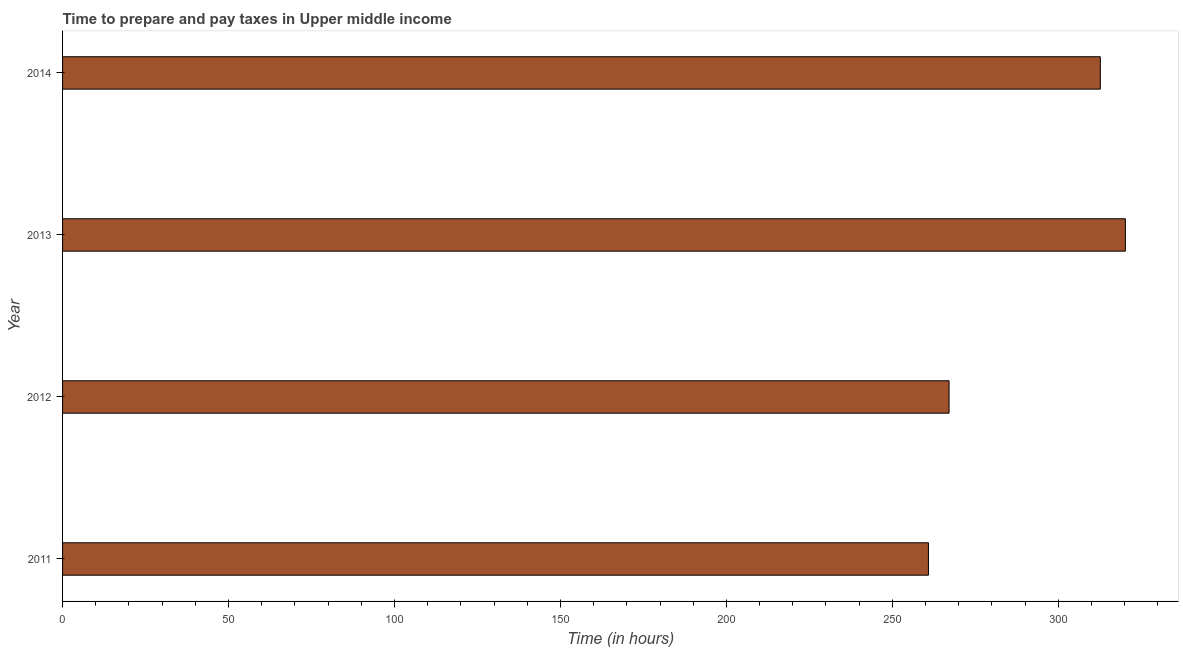Does the graph contain any zero values?
Your answer should be very brief. No. What is the title of the graph?
Give a very brief answer. Time to prepare and pay taxes in Upper middle income. What is the label or title of the X-axis?
Your response must be concise. Time (in hours). What is the time to prepare and pay taxes in 2011?
Offer a terse response. 260.87. Across all years, what is the maximum time to prepare and pay taxes?
Your response must be concise. 320.19. Across all years, what is the minimum time to prepare and pay taxes?
Provide a short and direct response. 260.87. In which year was the time to prepare and pay taxes maximum?
Your response must be concise. 2013. What is the sum of the time to prepare and pay taxes?
Ensure brevity in your answer.  1160.8. What is the difference between the time to prepare and pay taxes in 2011 and 2012?
Your answer should be very brief. -6.22. What is the average time to prepare and pay taxes per year?
Make the answer very short. 290.2. What is the median time to prepare and pay taxes?
Keep it short and to the point. 289.87. Do a majority of the years between 2013 and 2012 (inclusive) have time to prepare and pay taxes greater than 140 hours?
Keep it short and to the point. No. What is the ratio of the time to prepare and pay taxes in 2013 to that in 2014?
Keep it short and to the point. 1.02. Is the time to prepare and pay taxes in 2012 less than that in 2013?
Your response must be concise. Yes. What is the difference between the highest and the second highest time to prepare and pay taxes?
Your response must be concise. 7.54. Is the sum of the time to prepare and pay taxes in 2013 and 2014 greater than the maximum time to prepare and pay taxes across all years?
Offer a very short reply. Yes. What is the difference between the highest and the lowest time to prepare and pay taxes?
Offer a very short reply. 59.33. In how many years, is the time to prepare and pay taxes greater than the average time to prepare and pay taxes taken over all years?
Provide a succinct answer. 2. Are the values on the major ticks of X-axis written in scientific E-notation?
Keep it short and to the point. No. What is the Time (in hours) of 2011?
Your answer should be very brief. 260.87. What is the Time (in hours) of 2012?
Offer a very short reply. 267.09. What is the Time (in hours) of 2013?
Give a very brief answer. 320.19. What is the Time (in hours) of 2014?
Make the answer very short. 312.65. What is the difference between the Time (in hours) in 2011 and 2012?
Your response must be concise. -6.22. What is the difference between the Time (in hours) in 2011 and 2013?
Give a very brief answer. -59.33. What is the difference between the Time (in hours) in 2011 and 2014?
Your response must be concise. -51.79. What is the difference between the Time (in hours) in 2012 and 2013?
Provide a succinct answer. -53.11. What is the difference between the Time (in hours) in 2012 and 2014?
Keep it short and to the point. -45.57. What is the difference between the Time (in hours) in 2013 and 2014?
Provide a short and direct response. 7.54. What is the ratio of the Time (in hours) in 2011 to that in 2012?
Give a very brief answer. 0.98. What is the ratio of the Time (in hours) in 2011 to that in 2013?
Ensure brevity in your answer.  0.81. What is the ratio of the Time (in hours) in 2011 to that in 2014?
Your response must be concise. 0.83. What is the ratio of the Time (in hours) in 2012 to that in 2013?
Keep it short and to the point. 0.83. What is the ratio of the Time (in hours) in 2012 to that in 2014?
Offer a terse response. 0.85. What is the ratio of the Time (in hours) in 2013 to that in 2014?
Your answer should be compact. 1.02. 